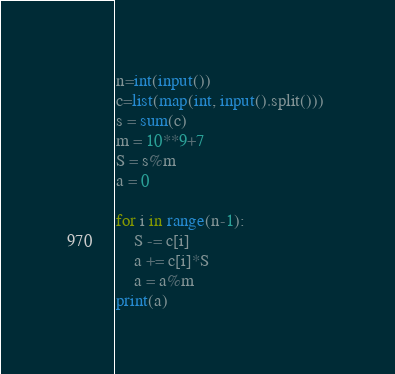<code> <loc_0><loc_0><loc_500><loc_500><_Python_>n=int(input())
c=list(map(int, input().split())) 
s = sum(c)
m = 10**9+7
S = s%m
a = 0

for i in range(n-1):
    S -= c[i]
    a += c[i]*S
    a = a%m
print(a)</code> 